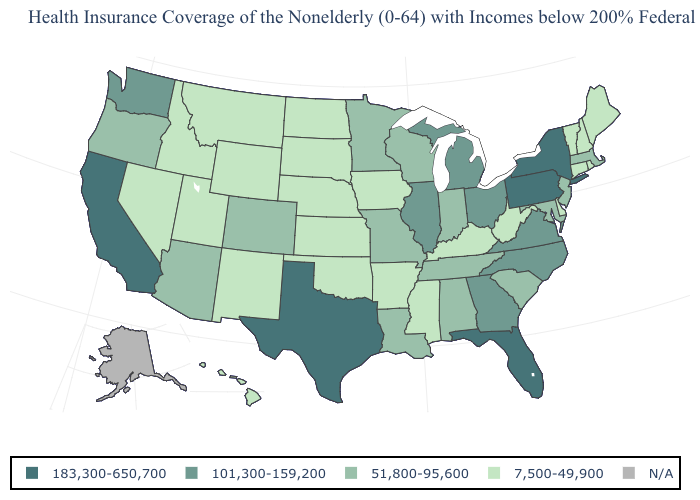Name the states that have a value in the range N/A?
Quick response, please. Alaska. What is the value of Tennessee?
Keep it brief. 51,800-95,600. Which states hav the highest value in the MidWest?
Quick response, please. Illinois, Michigan, Ohio. What is the value of Kentucky?
Concise answer only. 7,500-49,900. Does the map have missing data?
Be succinct. Yes. What is the highest value in the MidWest ?
Answer briefly. 101,300-159,200. Among the states that border Mississippi , does Arkansas have the lowest value?
Concise answer only. Yes. What is the value of Idaho?
Short answer required. 7,500-49,900. What is the lowest value in the South?
Write a very short answer. 7,500-49,900. What is the value of Nevada?
Keep it brief. 7,500-49,900. Among the states that border South Carolina , which have the lowest value?
Answer briefly. Georgia, North Carolina. Among the states that border Kentucky , which have the lowest value?
Short answer required. West Virginia. Name the states that have a value in the range 51,800-95,600?
Quick response, please. Alabama, Arizona, Colorado, Indiana, Louisiana, Maryland, Massachusetts, Minnesota, Missouri, New Jersey, Oregon, South Carolina, Tennessee, Wisconsin. 